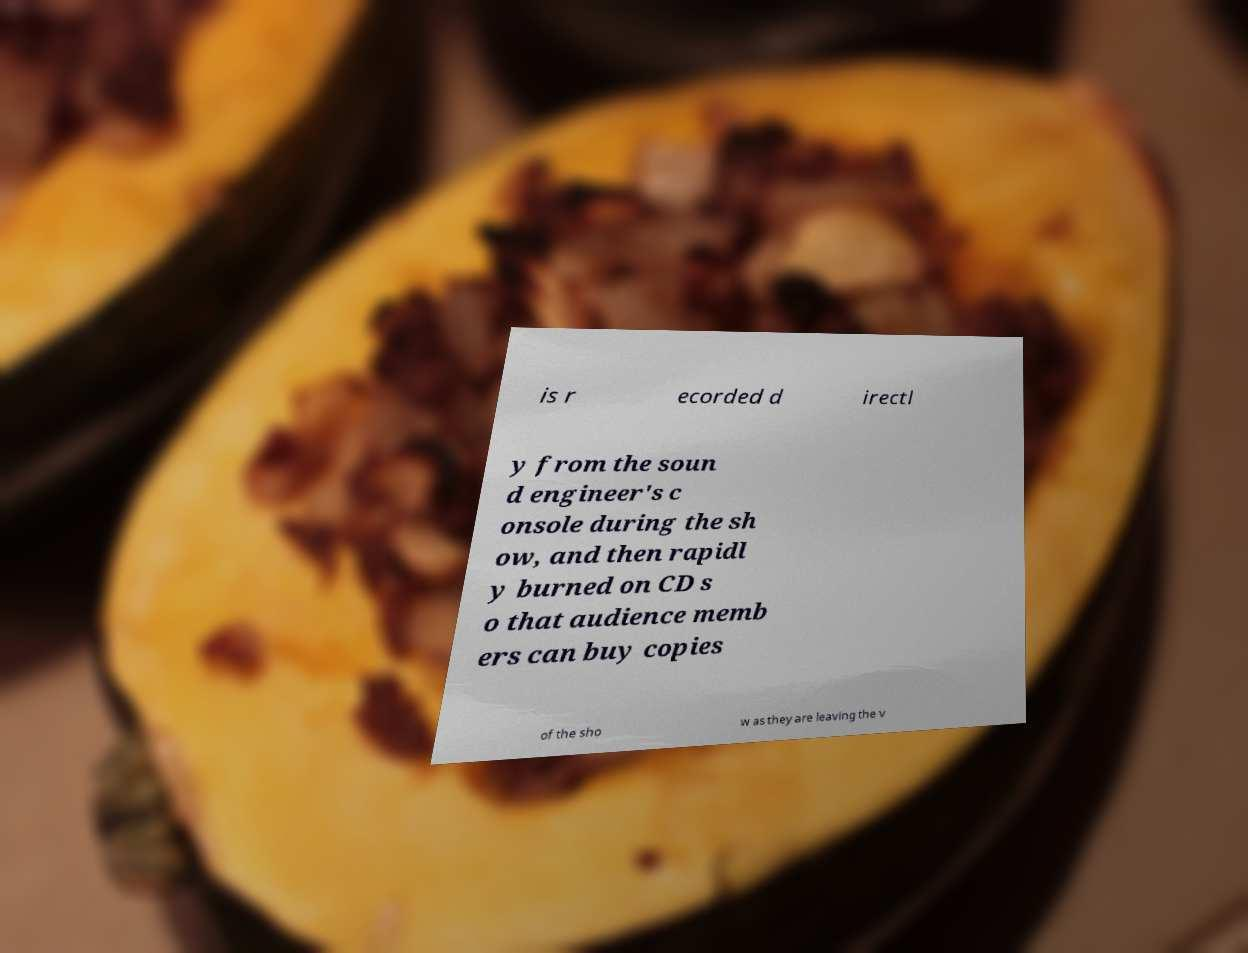I need the written content from this picture converted into text. Can you do that? is r ecorded d irectl y from the soun d engineer's c onsole during the sh ow, and then rapidl y burned on CD s o that audience memb ers can buy copies of the sho w as they are leaving the v 